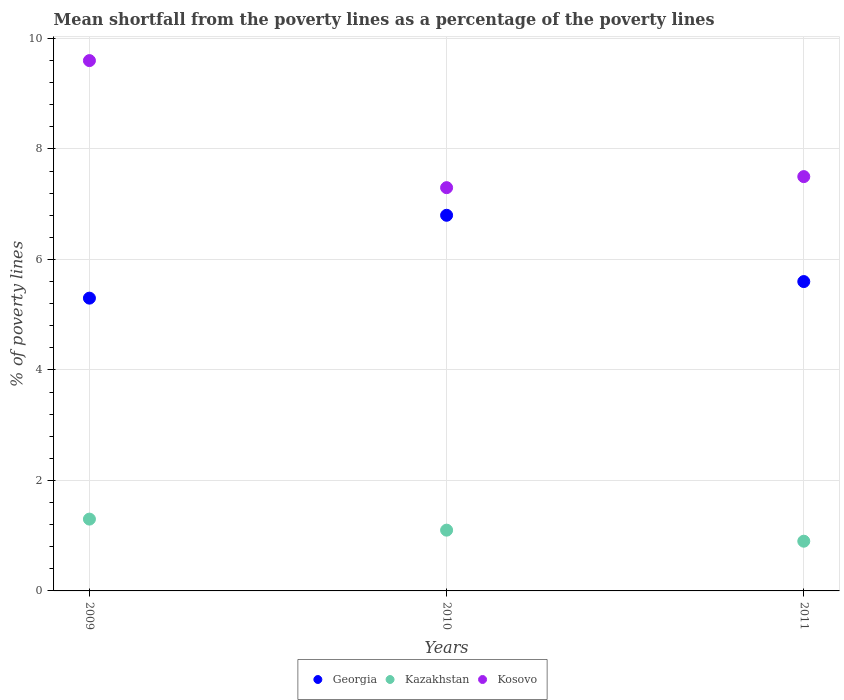How many different coloured dotlines are there?
Your answer should be compact. 3. Across all years, what is the minimum mean shortfall from the poverty lines as a percentage of the poverty lines in Georgia?
Offer a very short reply. 5.3. In which year was the mean shortfall from the poverty lines as a percentage of the poverty lines in Georgia minimum?
Offer a terse response. 2009. What is the total mean shortfall from the poverty lines as a percentage of the poverty lines in Kazakhstan in the graph?
Ensure brevity in your answer.  3.3. What is the difference between the mean shortfall from the poverty lines as a percentage of the poverty lines in Georgia in 2009 and that in 2011?
Provide a short and direct response. -0.3. What is the difference between the mean shortfall from the poverty lines as a percentage of the poverty lines in Kazakhstan in 2010 and the mean shortfall from the poverty lines as a percentage of the poverty lines in Georgia in 2009?
Your answer should be compact. -4.2. What is the average mean shortfall from the poverty lines as a percentage of the poverty lines in Kazakhstan per year?
Your answer should be compact. 1.1. In the year 2009, what is the difference between the mean shortfall from the poverty lines as a percentage of the poverty lines in Georgia and mean shortfall from the poverty lines as a percentage of the poverty lines in Kosovo?
Your answer should be very brief. -4.3. What is the ratio of the mean shortfall from the poverty lines as a percentage of the poverty lines in Georgia in 2010 to that in 2011?
Your response must be concise. 1.21. Is the difference between the mean shortfall from the poverty lines as a percentage of the poverty lines in Georgia in 2010 and 2011 greater than the difference between the mean shortfall from the poverty lines as a percentage of the poverty lines in Kosovo in 2010 and 2011?
Keep it short and to the point. Yes. What is the difference between the highest and the second highest mean shortfall from the poverty lines as a percentage of the poverty lines in Georgia?
Offer a very short reply. 1.2. What is the difference between the highest and the lowest mean shortfall from the poverty lines as a percentage of the poverty lines in Kazakhstan?
Make the answer very short. 0.4. In how many years, is the mean shortfall from the poverty lines as a percentage of the poverty lines in Kosovo greater than the average mean shortfall from the poverty lines as a percentage of the poverty lines in Kosovo taken over all years?
Provide a short and direct response. 1. Is the sum of the mean shortfall from the poverty lines as a percentage of the poverty lines in Georgia in 2009 and 2011 greater than the maximum mean shortfall from the poverty lines as a percentage of the poverty lines in Kosovo across all years?
Make the answer very short. Yes. Is it the case that in every year, the sum of the mean shortfall from the poverty lines as a percentage of the poverty lines in Kazakhstan and mean shortfall from the poverty lines as a percentage of the poverty lines in Georgia  is greater than the mean shortfall from the poverty lines as a percentage of the poverty lines in Kosovo?
Offer a terse response. No. Are the values on the major ticks of Y-axis written in scientific E-notation?
Provide a succinct answer. No. Does the graph contain grids?
Keep it short and to the point. Yes. Where does the legend appear in the graph?
Make the answer very short. Bottom center. What is the title of the graph?
Provide a succinct answer. Mean shortfall from the poverty lines as a percentage of the poverty lines. Does "France" appear as one of the legend labels in the graph?
Provide a succinct answer. No. What is the label or title of the X-axis?
Make the answer very short. Years. What is the label or title of the Y-axis?
Provide a succinct answer. % of poverty lines. What is the % of poverty lines in Kosovo in 2009?
Your answer should be compact. 9.6. What is the % of poverty lines in Georgia in 2010?
Give a very brief answer. 6.8. What is the % of poverty lines of Kosovo in 2010?
Make the answer very short. 7.3. What is the % of poverty lines of Georgia in 2011?
Keep it short and to the point. 5.6. What is the % of poverty lines in Kosovo in 2011?
Ensure brevity in your answer.  7.5. Across all years, what is the maximum % of poverty lines of Georgia?
Keep it short and to the point. 6.8. Across all years, what is the maximum % of poverty lines of Kazakhstan?
Provide a succinct answer. 1.3. Across all years, what is the maximum % of poverty lines of Kosovo?
Your answer should be compact. 9.6. What is the total % of poverty lines in Georgia in the graph?
Offer a terse response. 17.7. What is the total % of poverty lines in Kazakhstan in the graph?
Give a very brief answer. 3.3. What is the total % of poverty lines of Kosovo in the graph?
Your answer should be compact. 24.4. What is the difference between the % of poverty lines in Kazakhstan in 2009 and that in 2010?
Keep it short and to the point. 0.2. What is the difference between the % of poverty lines in Kosovo in 2009 and that in 2010?
Offer a very short reply. 2.3. What is the difference between the % of poverty lines of Kazakhstan in 2009 and that in 2011?
Provide a succinct answer. 0.4. What is the difference between the % of poverty lines in Kosovo in 2009 and that in 2011?
Offer a terse response. 2.1. What is the difference between the % of poverty lines of Georgia in 2009 and the % of poverty lines of Kazakhstan in 2010?
Give a very brief answer. 4.2. What is the difference between the % of poverty lines in Georgia in 2009 and the % of poverty lines in Kosovo in 2011?
Offer a terse response. -2.2. What is the difference between the % of poverty lines of Kazakhstan in 2009 and the % of poverty lines of Kosovo in 2011?
Offer a terse response. -6.2. What is the difference between the % of poverty lines of Kazakhstan in 2010 and the % of poverty lines of Kosovo in 2011?
Give a very brief answer. -6.4. What is the average % of poverty lines of Kazakhstan per year?
Make the answer very short. 1.1. What is the average % of poverty lines in Kosovo per year?
Offer a very short reply. 8.13. In the year 2009, what is the difference between the % of poverty lines of Georgia and % of poverty lines of Kosovo?
Your response must be concise. -4.3. In the year 2009, what is the difference between the % of poverty lines of Kazakhstan and % of poverty lines of Kosovo?
Give a very brief answer. -8.3. In the year 2011, what is the difference between the % of poverty lines in Kazakhstan and % of poverty lines in Kosovo?
Make the answer very short. -6.6. What is the ratio of the % of poverty lines of Georgia in 2009 to that in 2010?
Your answer should be very brief. 0.78. What is the ratio of the % of poverty lines in Kazakhstan in 2009 to that in 2010?
Keep it short and to the point. 1.18. What is the ratio of the % of poverty lines in Kosovo in 2009 to that in 2010?
Give a very brief answer. 1.32. What is the ratio of the % of poverty lines of Georgia in 2009 to that in 2011?
Your answer should be compact. 0.95. What is the ratio of the % of poverty lines of Kazakhstan in 2009 to that in 2011?
Make the answer very short. 1.44. What is the ratio of the % of poverty lines in Kosovo in 2009 to that in 2011?
Your response must be concise. 1.28. What is the ratio of the % of poverty lines in Georgia in 2010 to that in 2011?
Make the answer very short. 1.21. What is the ratio of the % of poverty lines in Kazakhstan in 2010 to that in 2011?
Offer a very short reply. 1.22. What is the ratio of the % of poverty lines of Kosovo in 2010 to that in 2011?
Your response must be concise. 0.97. What is the difference between the highest and the lowest % of poverty lines of Georgia?
Keep it short and to the point. 1.5. 